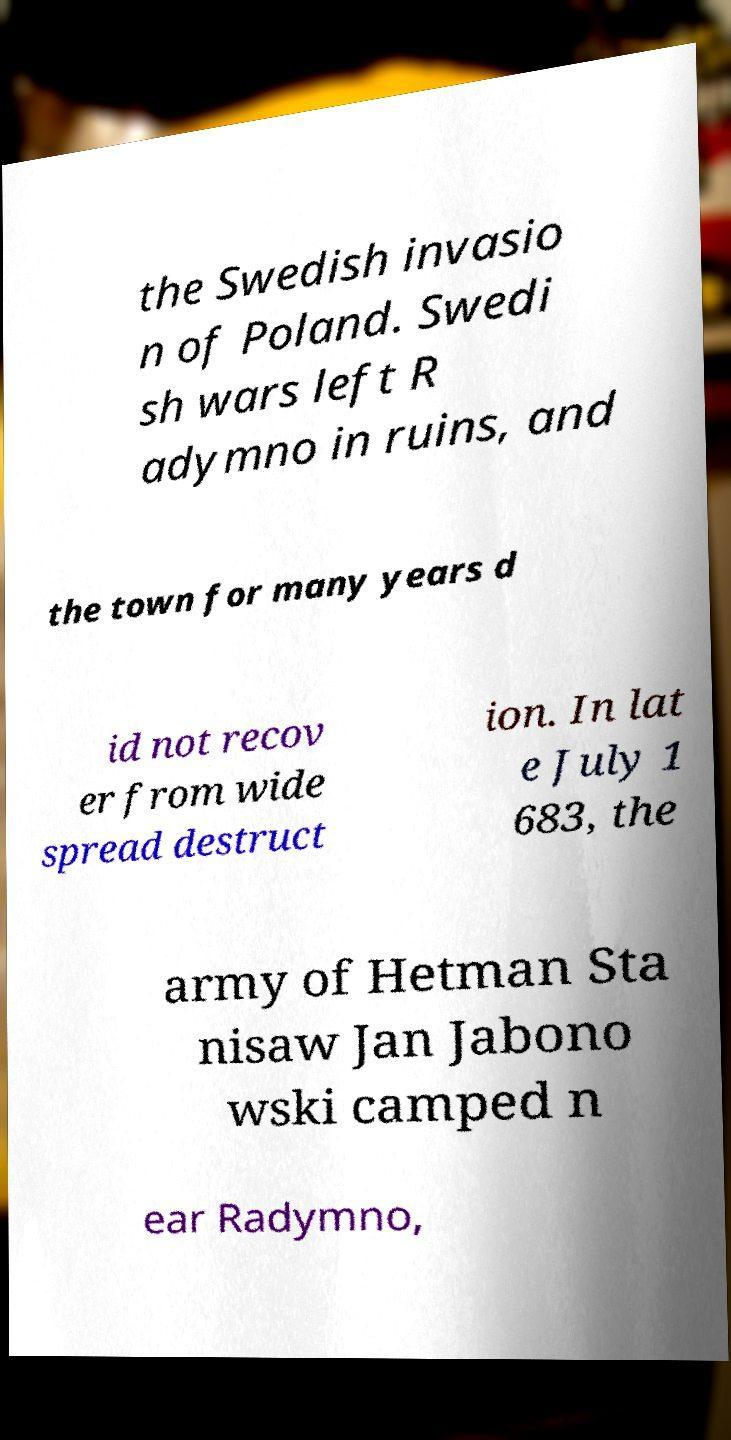What messages or text are displayed in this image? I need them in a readable, typed format. the Swedish invasio n of Poland. Swedi sh wars left R adymno in ruins, and the town for many years d id not recov er from wide spread destruct ion. In lat e July 1 683, the army of Hetman Sta nisaw Jan Jabono wski camped n ear Radymno, 